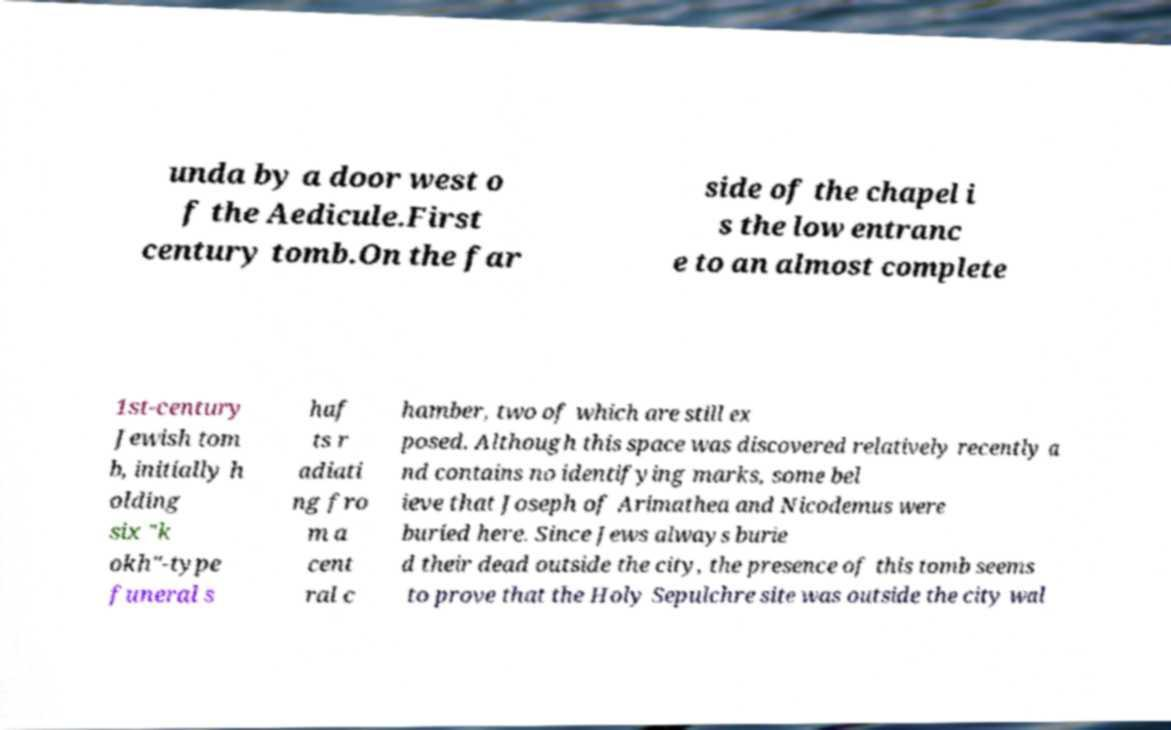Can you read and provide the text displayed in the image?This photo seems to have some interesting text. Can you extract and type it out for me? unda by a door west o f the Aedicule.First century tomb.On the far side of the chapel i s the low entranc e to an almost complete 1st-century Jewish tom b, initially h olding six "k okh"-type funeral s haf ts r adiati ng fro m a cent ral c hamber, two of which are still ex posed. Although this space was discovered relatively recently a nd contains no identifying marks, some bel ieve that Joseph of Arimathea and Nicodemus were buried here. Since Jews always burie d their dead outside the city, the presence of this tomb seems to prove that the Holy Sepulchre site was outside the city wal 